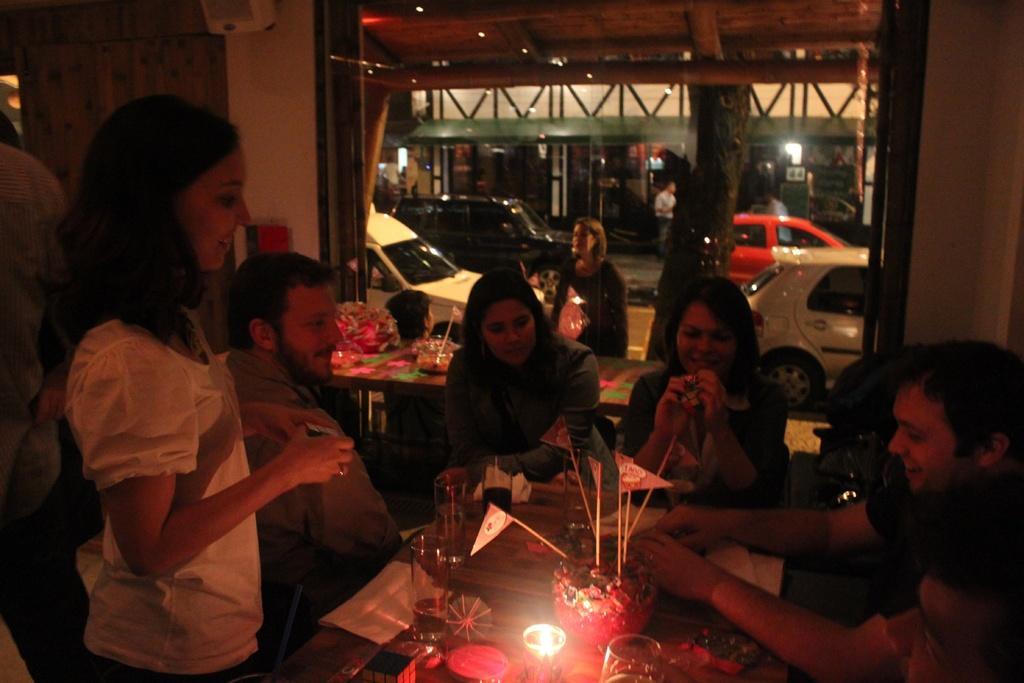Can you describe this image briefly? In this image there are a few tables, on which there are glasses, flags and other objects are arranged, around the table there are a few people sitting and standing with a smile on their face. In the background there are a few vehicles are moving on the road, there is a tree and a few people are walking on the pavement and there is another building. 